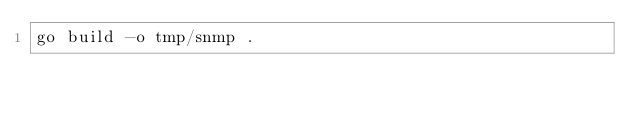Convert code to text. <code><loc_0><loc_0><loc_500><loc_500><_Bash_>go build -o tmp/snmp .</code> 